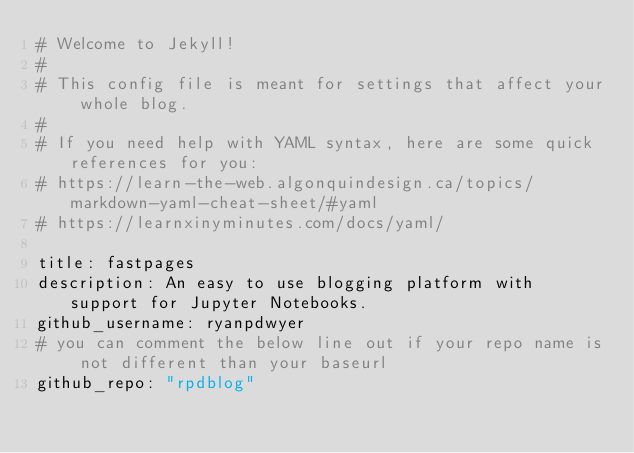<code> <loc_0><loc_0><loc_500><loc_500><_YAML_># Welcome to Jekyll!
#
# This config file is meant for settings that affect your whole blog.
#
# If you need help with YAML syntax, here are some quick references for you: 
# https://learn-the-web.algonquindesign.ca/topics/markdown-yaml-cheat-sheet/#yaml
# https://learnxinyminutes.com/docs/yaml/

title: fastpages
description: An easy to use blogging platform with support for Jupyter Notebooks.
github_username: ryanpdwyer
# you can comment the below line out if your repo name is not different than your baseurl
github_repo: "rpdblog"
</code> 